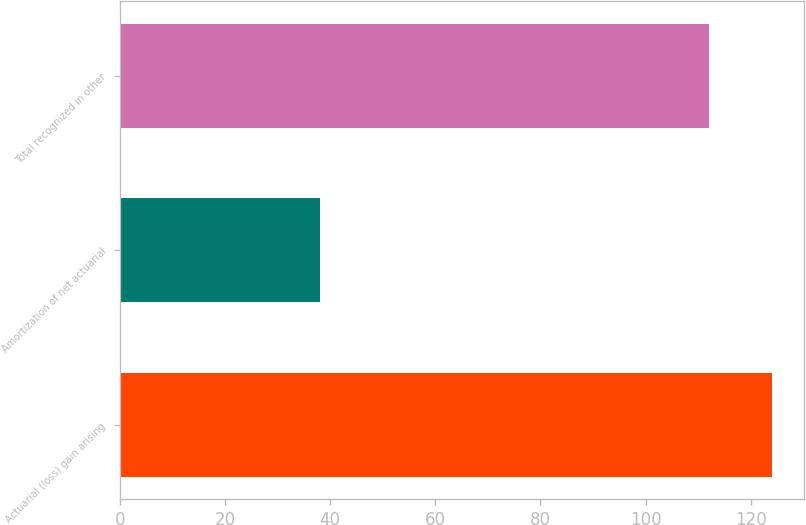Convert chart to OTSL. <chart><loc_0><loc_0><loc_500><loc_500><bar_chart><fcel>Actuarial (loss) gain arising<fcel>Amortization of net actuarial<fcel>Total recognized in other<nl><fcel>124<fcel>38<fcel>112<nl></chart> 